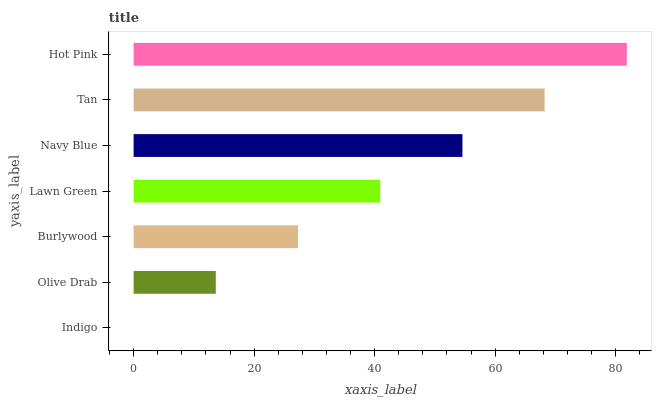Is Indigo the minimum?
Answer yes or no. Yes. Is Hot Pink the maximum?
Answer yes or no. Yes. Is Olive Drab the minimum?
Answer yes or no. No. Is Olive Drab the maximum?
Answer yes or no. No. Is Olive Drab greater than Indigo?
Answer yes or no. Yes. Is Indigo less than Olive Drab?
Answer yes or no. Yes. Is Indigo greater than Olive Drab?
Answer yes or no. No. Is Olive Drab less than Indigo?
Answer yes or no. No. Is Lawn Green the high median?
Answer yes or no. Yes. Is Lawn Green the low median?
Answer yes or no. Yes. Is Indigo the high median?
Answer yes or no. No. Is Indigo the low median?
Answer yes or no. No. 